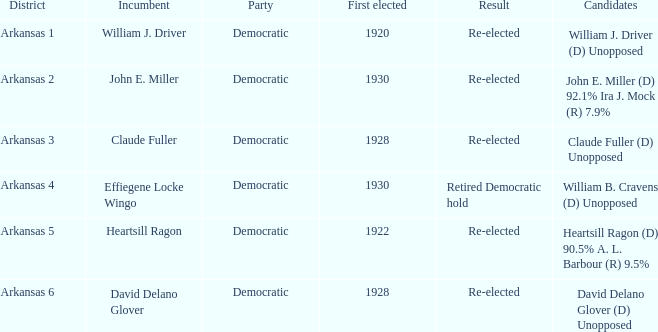What year did incumbent claude fuller win his first election? 1928.0. 